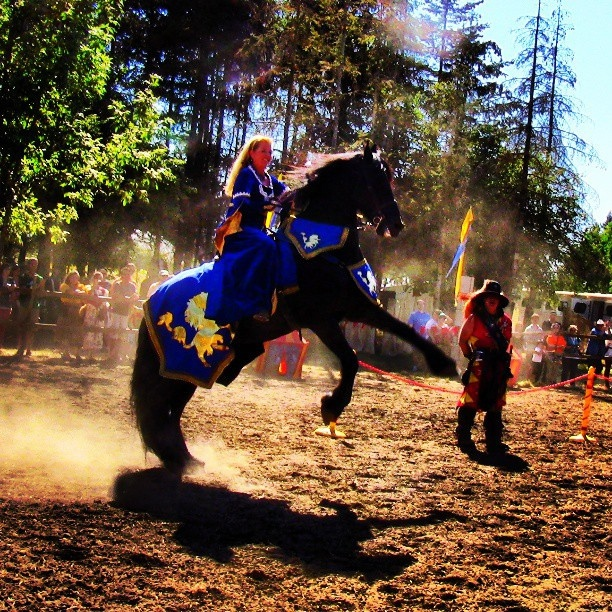Describe the objects in this image and their specific colors. I can see horse in darkgreen, black, navy, maroon, and darkblue tones, people in darkgreen, black, maroon, and brown tones, people in darkgreen, black, navy, brown, and maroon tones, truck in darkgreen, black, maroon, olive, and tan tones, and people in darkgreen, maroon, and brown tones in this image. 